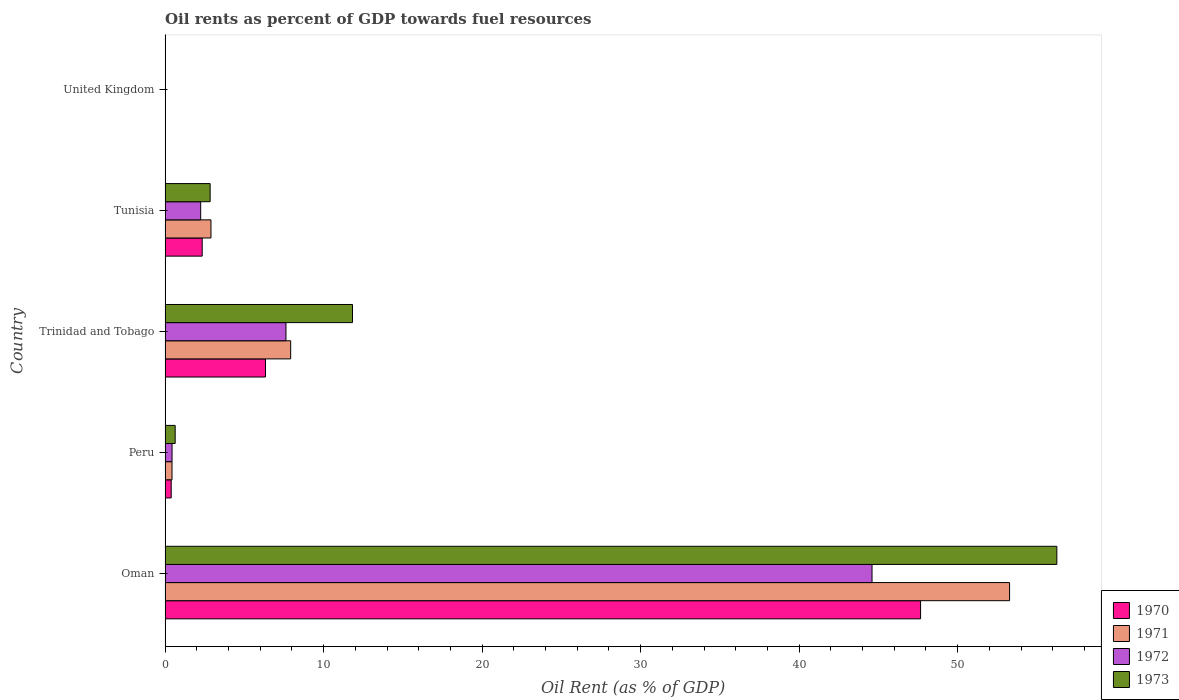Are the number of bars on each tick of the Y-axis equal?
Ensure brevity in your answer.  Yes. How many bars are there on the 2nd tick from the top?
Give a very brief answer. 4. What is the label of the 4th group of bars from the top?
Offer a terse response. Peru. In how many cases, is the number of bars for a given country not equal to the number of legend labels?
Your response must be concise. 0. What is the oil rent in 1970 in Trinidad and Tobago?
Provide a succinct answer. 6.33. Across all countries, what is the maximum oil rent in 1973?
Provide a succinct answer. 56.26. Across all countries, what is the minimum oil rent in 1970?
Provide a short and direct response. 0. In which country was the oil rent in 1973 maximum?
Your answer should be very brief. Oman. In which country was the oil rent in 1971 minimum?
Make the answer very short. United Kingdom. What is the total oil rent in 1973 in the graph?
Your answer should be compact. 71.56. What is the difference between the oil rent in 1970 in Peru and that in Tunisia?
Provide a short and direct response. -1.95. What is the difference between the oil rent in 1970 in United Kingdom and the oil rent in 1972 in Peru?
Your answer should be very brief. -0.44. What is the average oil rent in 1972 per country?
Provide a short and direct response. 10.98. What is the difference between the oil rent in 1971 and oil rent in 1972 in Tunisia?
Offer a terse response. 0.65. In how many countries, is the oil rent in 1972 greater than 12 %?
Ensure brevity in your answer.  1. What is the ratio of the oil rent in 1972 in Peru to that in Trinidad and Tobago?
Your response must be concise. 0.06. Is the oil rent in 1971 in Peru less than that in United Kingdom?
Provide a short and direct response. No. What is the difference between the highest and the second highest oil rent in 1970?
Your answer should be very brief. 41.33. What is the difference between the highest and the lowest oil rent in 1973?
Give a very brief answer. 56.26. Is the sum of the oil rent in 1971 in Oman and Trinidad and Tobago greater than the maximum oil rent in 1973 across all countries?
Keep it short and to the point. Yes. What does the 3rd bar from the bottom in Trinidad and Tobago represents?
Ensure brevity in your answer.  1972. Is it the case that in every country, the sum of the oil rent in 1970 and oil rent in 1971 is greater than the oil rent in 1973?
Provide a short and direct response. No. How many bars are there?
Offer a terse response. 20. Are all the bars in the graph horizontal?
Your answer should be compact. Yes. How many countries are there in the graph?
Provide a short and direct response. 5. Are the values on the major ticks of X-axis written in scientific E-notation?
Your answer should be very brief. No. Does the graph contain any zero values?
Provide a short and direct response. No. Where does the legend appear in the graph?
Keep it short and to the point. Bottom right. How many legend labels are there?
Your response must be concise. 4. What is the title of the graph?
Provide a succinct answer. Oil rents as percent of GDP towards fuel resources. Does "1974" appear as one of the legend labels in the graph?
Your answer should be compact. No. What is the label or title of the X-axis?
Your answer should be very brief. Oil Rent (as % of GDP). What is the Oil Rent (as % of GDP) in 1970 in Oman?
Provide a short and direct response. 47.66. What is the Oil Rent (as % of GDP) of 1971 in Oman?
Provide a short and direct response. 53.28. What is the Oil Rent (as % of GDP) of 1972 in Oman?
Your answer should be compact. 44.6. What is the Oil Rent (as % of GDP) in 1973 in Oman?
Offer a terse response. 56.26. What is the Oil Rent (as % of GDP) in 1970 in Peru?
Offer a terse response. 0.39. What is the Oil Rent (as % of GDP) of 1971 in Peru?
Provide a succinct answer. 0.44. What is the Oil Rent (as % of GDP) of 1972 in Peru?
Give a very brief answer. 0.44. What is the Oil Rent (as % of GDP) of 1973 in Peru?
Keep it short and to the point. 0.64. What is the Oil Rent (as % of GDP) of 1970 in Trinidad and Tobago?
Your answer should be very brief. 6.33. What is the Oil Rent (as % of GDP) in 1971 in Trinidad and Tobago?
Your answer should be compact. 7.92. What is the Oil Rent (as % of GDP) of 1972 in Trinidad and Tobago?
Keep it short and to the point. 7.63. What is the Oil Rent (as % of GDP) in 1973 in Trinidad and Tobago?
Provide a short and direct response. 11.82. What is the Oil Rent (as % of GDP) of 1970 in Tunisia?
Ensure brevity in your answer.  2.34. What is the Oil Rent (as % of GDP) in 1971 in Tunisia?
Keep it short and to the point. 2.89. What is the Oil Rent (as % of GDP) in 1972 in Tunisia?
Your answer should be very brief. 2.25. What is the Oil Rent (as % of GDP) in 1973 in Tunisia?
Your response must be concise. 2.84. What is the Oil Rent (as % of GDP) in 1970 in United Kingdom?
Your answer should be compact. 0. What is the Oil Rent (as % of GDP) of 1971 in United Kingdom?
Your answer should be very brief. 0. What is the Oil Rent (as % of GDP) of 1972 in United Kingdom?
Your answer should be compact. 0. What is the Oil Rent (as % of GDP) of 1973 in United Kingdom?
Offer a very short reply. 0. Across all countries, what is the maximum Oil Rent (as % of GDP) in 1970?
Your answer should be very brief. 47.66. Across all countries, what is the maximum Oil Rent (as % of GDP) of 1971?
Make the answer very short. 53.28. Across all countries, what is the maximum Oil Rent (as % of GDP) of 1972?
Your response must be concise. 44.6. Across all countries, what is the maximum Oil Rent (as % of GDP) in 1973?
Offer a very short reply. 56.26. Across all countries, what is the minimum Oil Rent (as % of GDP) of 1970?
Your response must be concise. 0. Across all countries, what is the minimum Oil Rent (as % of GDP) in 1971?
Your answer should be compact. 0. Across all countries, what is the minimum Oil Rent (as % of GDP) of 1972?
Your response must be concise. 0. Across all countries, what is the minimum Oil Rent (as % of GDP) of 1973?
Make the answer very short. 0. What is the total Oil Rent (as % of GDP) in 1970 in the graph?
Ensure brevity in your answer.  56.72. What is the total Oil Rent (as % of GDP) in 1971 in the graph?
Keep it short and to the point. 64.53. What is the total Oil Rent (as % of GDP) in 1972 in the graph?
Offer a very short reply. 54.91. What is the total Oil Rent (as % of GDP) of 1973 in the graph?
Offer a terse response. 71.56. What is the difference between the Oil Rent (as % of GDP) in 1970 in Oman and that in Peru?
Give a very brief answer. 47.28. What is the difference between the Oil Rent (as % of GDP) of 1971 in Oman and that in Peru?
Your answer should be very brief. 52.84. What is the difference between the Oil Rent (as % of GDP) in 1972 in Oman and that in Peru?
Offer a terse response. 44.16. What is the difference between the Oil Rent (as % of GDP) in 1973 in Oman and that in Peru?
Offer a terse response. 55.62. What is the difference between the Oil Rent (as % of GDP) in 1970 in Oman and that in Trinidad and Tobago?
Offer a very short reply. 41.33. What is the difference between the Oil Rent (as % of GDP) of 1971 in Oman and that in Trinidad and Tobago?
Provide a short and direct response. 45.35. What is the difference between the Oil Rent (as % of GDP) of 1972 in Oman and that in Trinidad and Tobago?
Give a very brief answer. 36.97. What is the difference between the Oil Rent (as % of GDP) in 1973 in Oman and that in Trinidad and Tobago?
Ensure brevity in your answer.  44.44. What is the difference between the Oil Rent (as % of GDP) of 1970 in Oman and that in Tunisia?
Offer a terse response. 45.32. What is the difference between the Oil Rent (as % of GDP) of 1971 in Oman and that in Tunisia?
Your response must be concise. 50.38. What is the difference between the Oil Rent (as % of GDP) in 1972 in Oman and that in Tunisia?
Offer a terse response. 42.36. What is the difference between the Oil Rent (as % of GDP) of 1973 in Oman and that in Tunisia?
Your response must be concise. 53.42. What is the difference between the Oil Rent (as % of GDP) in 1970 in Oman and that in United Kingdom?
Your answer should be compact. 47.66. What is the difference between the Oil Rent (as % of GDP) of 1971 in Oman and that in United Kingdom?
Give a very brief answer. 53.28. What is the difference between the Oil Rent (as % of GDP) in 1972 in Oman and that in United Kingdom?
Your response must be concise. 44.6. What is the difference between the Oil Rent (as % of GDP) of 1973 in Oman and that in United Kingdom?
Your answer should be compact. 56.26. What is the difference between the Oil Rent (as % of GDP) in 1970 in Peru and that in Trinidad and Tobago?
Make the answer very short. -5.95. What is the difference between the Oil Rent (as % of GDP) in 1971 in Peru and that in Trinidad and Tobago?
Keep it short and to the point. -7.49. What is the difference between the Oil Rent (as % of GDP) in 1972 in Peru and that in Trinidad and Tobago?
Your answer should be very brief. -7.19. What is the difference between the Oil Rent (as % of GDP) in 1973 in Peru and that in Trinidad and Tobago?
Your answer should be very brief. -11.19. What is the difference between the Oil Rent (as % of GDP) in 1970 in Peru and that in Tunisia?
Your answer should be compact. -1.95. What is the difference between the Oil Rent (as % of GDP) in 1971 in Peru and that in Tunisia?
Your answer should be compact. -2.46. What is the difference between the Oil Rent (as % of GDP) of 1972 in Peru and that in Tunisia?
Provide a short and direct response. -1.81. What is the difference between the Oil Rent (as % of GDP) in 1973 in Peru and that in Tunisia?
Keep it short and to the point. -2.21. What is the difference between the Oil Rent (as % of GDP) of 1970 in Peru and that in United Kingdom?
Your answer should be very brief. 0.38. What is the difference between the Oil Rent (as % of GDP) of 1971 in Peru and that in United Kingdom?
Keep it short and to the point. 0.44. What is the difference between the Oil Rent (as % of GDP) of 1972 in Peru and that in United Kingdom?
Provide a succinct answer. 0.44. What is the difference between the Oil Rent (as % of GDP) in 1973 in Peru and that in United Kingdom?
Your answer should be compact. 0.63. What is the difference between the Oil Rent (as % of GDP) of 1970 in Trinidad and Tobago and that in Tunisia?
Offer a very short reply. 3.99. What is the difference between the Oil Rent (as % of GDP) in 1971 in Trinidad and Tobago and that in Tunisia?
Offer a terse response. 5.03. What is the difference between the Oil Rent (as % of GDP) in 1972 in Trinidad and Tobago and that in Tunisia?
Your answer should be compact. 5.38. What is the difference between the Oil Rent (as % of GDP) of 1973 in Trinidad and Tobago and that in Tunisia?
Keep it short and to the point. 8.98. What is the difference between the Oil Rent (as % of GDP) of 1970 in Trinidad and Tobago and that in United Kingdom?
Offer a terse response. 6.33. What is the difference between the Oil Rent (as % of GDP) in 1971 in Trinidad and Tobago and that in United Kingdom?
Your answer should be compact. 7.92. What is the difference between the Oil Rent (as % of GDP) of 1972 in Trinidad and Tobago and that in United Kingdom?
Your answer should be very brief. 7.62. What is the difference between the Oil Rent (as % of GDP) of 1973 in Trinidad and Tobago and that in United Kingdom?
Offer a terse response. 11.82. What is the difference between the Oil Rent (as % of GDP) of 1970 in Tunisia and that in United Kingdom?
Keep it short and to the point. 2.34. What is the difference between the Oil Rent (as % of GDP) in 1971 in Tunisia and that in United Kingdom?
Give a very brief answer. 2.89. What is the difference between the Oil Rent (as % of GDP) in 1972 in Tunisia and that in United Kingdom?
Your response must be concise. 2.24. What is the difference between the Oil Rent (as % of GDP) in 1973 in Tunisia and that in United Kingdom?
Provide a short and direct response. 2.84. What is the difference between the Oil Rent (as % of GDP) of 1970 in Oman and the Oil Rent (as % of GDP) of 1971 in Peru?
Provide a succinct answer. 47.23. What is the difference between the Oil Rent (as % of GDP) of 1970 in Oman and the Oil Rent (as % of GDP) of 1972 in Peru?
Offer a very short reply. 47.22. What is the difference between the Oil Rent (as % of GDP) of 1970 in Oman and the Oil Rent (as % of GDP) of 1973 in Peru?
Offer a terse response. 47.03. What is the difference between the Oil Rent (as % of GDP) of 1971 in Oman and the Oil Rent (as % of GDP) of 1972 in Peru?
Your response must be concise. 52.84. What is the difference between the Oil Rent (as % of GDP) in 1971 in Oman and the Oil Rent (as % of GDP) in 1973 in Peru?
Give a very brief answer. 52.64. What is the difference between the Oil Rent (as % of GDP) in 1972 in Oman and the Oil Rent (as % of GDP) in 1973 in Peru?
Give a very brief answer. 43.96. What is the difference between the Oil Rent (as % of GDP) in 1970 in Oman and the Oil Rent (as % of GDP) in 1971 in Trinidad and Tobago?
Ensure brevity in your answer.  39.74. What is the difference between the Oil Rent (as % of GDP) in 1970 in Oman and the Oil Rent (as % of GDP) in 1972 in Trinidad and Tobago?
Offer a very short reply. 40.04. What is the difference between the Oil Rent (as % of GDP) in 1970 in Oman and the Oil Rent (as % of GDP) in 1973 in Trinidad and Tobago?
Offer a terse response. 35.84. What is the difference between the Oil Rent (as % of GDP) in 1971 in Oman and the Oil Rent (as % of GDP) in 1972 in Trinidad and Tobago?
Give a very brief answer. 45.65. What is the difference between the Oil Rent (as % of GDP) in 1971 in Oman and the Oil Rent (as % of GDP) in 1973 in Trinidad and Tobago?
Your answer should be very brief. 41.45. What is the difference between the Oil Rent (as % of GDP) in 1972 in Oman and the Oil Rent (as % of GDP) in 1973 in Trinidad and Tobago?
Your answer should be compact. 32.78. What is the difference between the Oil Rent (as % of GDP) of 1970 in Oman and the Oil Rent (as % of GDP) of 1971 in Tunisia?
Offer a terse response. 44.77. What is the difference between the Oil Rent (as % of GDP) in 1970 in Oman and the Oil Rent (as % of GDP) in 1972 in Tunisia?
Provide a succinct answer. 45.42. What is the difference between the Oil Rent (as % of GDP) in 1970 in Oman and the Oil Rent (as % of GDP) in 1973 in Tunisia?
Your answer should be very brief. 44.82. What is the difference between the Oil Rent (as % of GDP) in 1971 in Oman and the Oil Rent (as % of GDP) in 1972 in Tunisia?
Make the answer very short. 51.03. What is the difference between the Oil Rent (as % of GDP) of 1971 in Oman and the Oil Rent (as % of GDP) of 1973 in Tunisia?
Make the answer very short. 50.43. What is the difference between the Oil Rent (as % of GDP) of 1972 in Oman and the Oil Rent (as % of GDP) of 1973 in Tunisia?
Your answer should be very brief. 41.76. What is the difference between the Oil Rent (as % of GDP) in 1970 in Oman and the Oil Rent (as % of GDP) in 1971 in United Kingdom?
Provide a short and direct response. 47.66. What is the difference between the Oil Rent (as % of GDP) in 1970 in Oman and the Oil Rent (as % of GDP) in 1972 in United Kingdom?
Keep it short and to the point. 47.66. What is the difference between the Oil Rent (as % of GDP) in 1970 in Oman and the Oil Rent (as % of GDP) in 1973 in United Kingdom?
Offer a very short reply. 47.66. What is the difference between the Oil Rent (as % of GDP) in 1971 in Oman and the Oil Rent (as % of GDP) in 1972 in United Kingdom?
Your answer should be compact. 53.28. What is the difference between the Oil Rent (as % of GDP) in 1971 in Oman and the Oil Rent (as % of GDP) in 1973 in United Kingdom?
Offer a very short reply. 53.27. What is the difference between the Oil Rent (as % of GDP) of 1972 in Oman and the Oil Rent (as % of GDP) of 1973 in United Kingdom?
Offer a very short reply. 44.6. What is the difference between the Oil Rent (as % of GDP) in 1970 in Peru and the Oil Rent (as % of GDP) in 1971 in Trinidad and Tobago?
Keep it short and to the point. -7.54. What is the difference between the Oil Rent (as % of GDP) of 1970 in Peru and the Oil Rent (as % of GDP) of 1972 in Trinidad and Tobago?
Keep it short and to the point. -7.24. What is the difference between the Oil Rent (as % of GDP) in 1970 in Peru and the Oil Rent (as % of GDP) in 1973 in Trinidad and Tobago?
Offer a very short reply. -11.44. What is the difference between the Oil Rent (as % of GDP) in 1971 in Peru and the Oil Rent (as % of GDP) in 1972 in Trinidad and Tobago?
Keep it short and to the point. -7.19. What is the difference between the Oil Rent (as % of GDP) of 1971 in Peru and the Oil Rent (as % of GDP) of 1973 in Trinidad and Tobago?
Make the answer very short. -11.39. What is the difference between the Oil Rent (as % of GDP) of 1972 in Peru and the Oil Rent (as % of GDP) of 1973 in Trinidad and Tobago?
Your answer should be very brief. -11.38. What is the difference between the Oil Rent (as % of GDP) of 1970 in Peru and the Oil Rent (as % of GDP) of 1971 in Tunisia?
Give a very brief answer. -2.51. What is the difference between the Oil Rent (as % of GDP) in 1970 in Peru and the Oil Rent (as % of GDP) in 1972 in Tunisia?
Keep it short and to the point. -1.86. What is the difference between the Oil Rent (as % of GDP) in 1970 in Peru and the Oil Rent (as % of GDP) in 1973 in Tunisia?
Offer a terse response. -2.46. What is the difference between the Oil Rent (as % of GDP) of 1971 in Peru and the Oil Rent (as % of GDP) of 1972 in Tunisia?
Provide a short and direct response. -1.81. What is the difference between the Oil Rent (as % of GDP) of 1971 in Peru and the Oil Rent (as % of GDP) of 1973 in Tunisia?
Your response must be concise. -2.4. What is the difference between the Oil Rent (as % of GDP) in 1972 in Peru and the Oil Rent (as % of GDP) in 1973 in Tunisia?
Ensure brevity in your answer.  -2.4. What is the difference between the Oil Rent (as % of GDP) of 1970 in Peru and the Oil Rent (as % of GDP) of 1971 in United Kingdom?
Ensure brevity in your answer.  0.38. What is the difference between the Oil Rent (as % of GDP) in 1970 in Peru and the Oil Rent (as % of GDP) in 1972 in United Kingdom?
Provide a short and direct response. 0.38. What is the difference between the Oil Rent (as % of GDP) in 1970 in Peru and the Oil Rent (as % of GDP) in 1973 in United Kingdom?
Make the answer very short. 0.38. What is the difference between the Oil Rent (as % of GDP) of 1971 in Peru and the Oil Rent (as % of GDP) of 1972 in United Kingdom?
Ensure brevity in your answer.  0.44. What is the difference between the Oil Rent (as % of GDP) in 1971 in Peru and the Oil Rent (as % of GDP) in 1973 in United Kingdom?
Provide a succinct answer. 0.43. What is the difference between the Oil Rent (as % of GDP) in 1972 in Peru and the Oil Rent (as % of GDP) in 1973 in United Kingdom?
Your answer should be compact. 0.44. What is the difference between the Oil Rent (as % of GDP) of 1970 in Trinidad and Tobago and the Oil Rent (as % of GDP) of 1971 in Tunisia?
Give a very brief answer. 3.44. What is the difference between the Oil Rent (as % of GDP) in 1970 in Trinidad and Tobago and the Oil Rent (as % of GDP) in 1972 in Tunisia?
Provide a short and direct response. 4.09. What is the difference between the Oil Rent (as % of GDP) in 1970 in Trinidad and Tobago and the Oil Rent (as % of GDP) in 1973 in Tunisia?
Offer a terse response. 3.49. What is the difference between the Oil Rent (as % of GDP) of 1971 in Trinidad and Tobago and the Oil Rent (as % of GDP) of 1972 in Tunisia?
Keep it short and to the point. 5.68. What is the difference between the Oil Rent (as % of GDP) in 1971 in Trinidad and Tobago and the Oil Rent (as % of GDP) in 1973 in Tunisia?
Provide a short and direct response. 5.08. What is the difference between the Oil Rent (as % of GDP) in 1972 in Trinidad and Tobago and the Oil Rent (as % of GDP) in 1973 in Tunisia?
Provide a short and direct response. 4.78. What is the difference between the Oil Rent (as % of GDP) in 1970 in Trinidad and Tobago and the Oil Rent (as % of GDP) in 1971 in United Kingdom?
Offer a very short reply. 6.33. What is the difference between the Oil Rent (as % of GDP) of 1970 in Trinidad and Tobago and the Oil Rent (as % of GDP) of 1972 in United Kingdom?
Provide a short and direct response. 6.33. What is the difference between the Oil Rent (as % of GDP) in 1970 in Trinidad and Tobago and the Oil Rent (as % of GDP) in 1973 in United Kingdom?
Provide a short and direct response. 6.33. What is the difference between the Oil Rent (as % of GDP) of 1971 in Trinidad and Tobago and the Oil Rent (as % of GDP) of 1972 in United Kingdom?
Keep it short and to the point. 7.92. What is the difference between the Oil Rent (as % of GDP) in 1971 in Trinidad and Tobago and the Oil Rent (as % of GDP) in 1973 in United Kingdom?
Your response must be concise. 7.92. What is the difference between the Oil Rent (as % of GDP) in 1972 in Trinidad and Tobago and the Oil Rent (as % of GDP) in 1973 in United Kingdom?
Make the answer very short. 7.62. What is the difference between the Oil Rent (as % of GDP) of 1970 in Tunisia and the Oil Rent (as % of GDP) of 1971 in United Kingdom?
Offer a very short reply. 2.34. What is the difference between the Oil Rent (as % of GDP) of 1970 in Tunisia and the Oil Rent (as % of GDP) of 1972 in United Kingdom?
Your response must be concise. 2.34. What is the difference between the Oil Rent (as % of GDP) in 1970 in Tunisia and the Oil Rent (as % of GDP) in 1973 in United Kingdom?
Your response must be concise. 2.34. What is the difference between the Oil Rent (as % of GDP) in 1971 in Tunisia and the Oil Rent (as % of GDP) in 1972 in United Kingdom?
Offer a terse response. 2.89. What is the difference between the Oil Rent (as % of GDP) of 1971 in Tunisia and the Oil Rent (as % of GDP) of 1973 in United Kingdom?
Provide a succinct answer. 2.89. What is the difference between the Oil Rent (as % of GDP) of 1972 in Tunisia and the Oil Rent (as % of GDP) of 1973 in United Kingdom?
Your response must be concise. 2.24. What is the average Oil Rent (as % of GDP) in 1970 per country?
Your answer should be very brief. 11.34. What is the average Oil Rent (as % of GDP) of 1971 per country?
Provide a short and direct response. 12.91. What is the average Oil Rent (as % of GDP) of 1972 per country?
Your response must be concise. 10.98. What is the average Oil Rent (as % of GDP) in 1973 per country?
Your answer should be compact. 14.31. What is the difference between the Oil Rent (as % of GDP) in 1970 and Oil Rent (as % of GDP) in 1971 in Oman?
Your answer should be compact. -5.61. What is the difference between the Oil Rent (as % of GDP) of 1970 and Oil Rent (as % of GDP) of 1972 in Oman?
Your response must be concise. 3.06. What is the difference between the Oil Rent (as % of GDP) of 1970 and Oil Rent (as % of GDP) of 1973 in Oman?
Your response must be concise. -8.6. What is the difference between the Oil Rent (as % of GDP) of 1971 and Oil Rent (as % of GDP) of 1972 in Oman?
Ensure brevity in your answer.  8.68. What is the difference between the Oil Rent (as % of GDP) in 1971 and Oil Rent (as % of GDP) in 1973 in Oman?
Make the answer very short. -2.98. What is the difference between the Oil Rent (as % of GDP) of 1972 and Oil Rent (as % of GDP) of 1973 in Oman?
Ensure brevity in your answer.  -11.66. What is the difference between the Oil Rent (as % of GDP) in 1970 and Oil Rent (as % of GDP) in 1971 in Peru?
Keep it short and to the point. -0.05. What is the difference between the Oil Rent (as % of GDP) of 1970 and Oil Rent (as % of GDP) of 1972 in Peru?
Give a very brief answer. -0.05. What is the difference between the Oil Rent (as % of GDP) of 1970 and Oil Rent (as % of GDP) of 1973 in Peru?
Make the answer very short. -0.25. What is the difference between the Oil Rent (as % of GDP) in 1971 and Oil Rent (as % of GDP) in 1972 in Peru?
Your answer should be very brief. -0. What is the difference between the Oil Rent (as % of GDP) in 1971 and Oil Rent (as % of GDP) in 1973 in Peru?
Your answer should be very brief. -0.2. What is the difference between the Oil Rent (as % of GDP) in 1972 and Oil Rent (as % of GDP) in 1973 in Peru?
Your response must be concise. -0.2. What is the difference between the Oil Rent (as % of GDP) of 1970 and Oil Rent (as % of GDP) of 1971 in Trinidad and Tobago?
Your answer should be very brief. -1.59. What is the difference between the Oil Rent (as % of GDP) in 1970 and Oil Rent (as % of GDP) in 1972 in Trinidad and Tobago?
Your response must be concise. -1.29. What is the difference between the Oil Rent (as % of GDP) of 1970 and Oil Rent (as % of GDP) of 1973 in Trinidad and Tobago?
Offer a terse response. -5.49. What is the difference between the Oil Rent (as % of GDP) in 1971 and Oil Rent (as % of GDP) in 1972 in Trinidad and Tobago?
Give a very brief answer. 0.3. What is the difference between the Oil Rent (as % of GDP) in 1971 and Oil Rent (as % of GDP) in 1973 in Trinidad and Tobago?
Provide a short and direct response. -3.9. What is the difference between the Oil Rent (as % of GDP) of 1972 and Oil Rent (as % of GDP) of 1973 in Trinidad and Tobago?
Your response must be concise. -4.2. What is the difference between the Oil Rent (as % of GDP) in 1970 and Oil Rent (as % of GDP) in 1971 in Tunisia?
Your answer should be very brief. -0.55. What is the difference between the Oil Rent (as % of GDP) in 1970 and Oil Rent (as % of GDP) in 1972 in Tunisia?
Make the answer very short. 0.1. What is the difference between the Oil Rent (as % of GDP) of 1970 and Oil Rent (as % of GDP) of 1973 in Tunisia?
Your answer should be very brief. -0.5. What is the difference between the Oil Rent (as % of GDP) of 1971 and Oil Rent (as % of GDP) of 1972 in Tunisia?
Ensure brevity in your answer.  0.65. What is the difference between the Oil Rent (as % of GDP) in 1971 and Oil Rent (as % of GDP) in 1973 in Tunisia?
Make the answer very short. 0.05. What is the difference between the Oil Rent (as % of GDP) in 1972 and Oil Rent (as % of GDP) in 1973 in Tunisia?
Give a very brief answer. -0.6. What is the difference between the Oil Rent (as % of GDP) in 1970 and Oil Rent (as % of GDP) in 1971 in United Kingdom?
Offer a terse response. 0. What is the difference between the Oil Rent (as % of GDP) in 1970 and Oil Rent (as % of GDP) in 1972 in United Kingdom?
Give a very brief answer. -0. What is the difference between the Oil Rent (as % of GDP) of 1970 and Oil Rent (as % of GDP) of 1973 in United Kingdom?
Give a very brief answer. -0. What is the difference between the Oil Rent (as % of GDP) in 1971 and Oil Rent (as % of GDP) in 1972 in United Kingdom?
Offer a terse response. -0. What is the difference between the Oil Rent (as % of GDP) in 1971 and Oil Rent (as % of GDP) in 1973 in United Kingdom?
Offer a very short reply. -0. What is the difference between the Oil Rent (as % of GDP) of 1972 and Oil Rent (as % of GDP) of 1973 in United Kingdom?
Offer a terse response. -0. What is the ratio of the Oil Rent (as % of GDP) in 1970 in Oman to that in Peru?
Your answer should be compact. 123.65. What is the ratio of the Oil Rent (as % of GDP) of 1971 in Oman to that in Peru?
Your answer should be compact. 121.98. What is the ratio of the Oil Rent (as % of GDP) in 1972 in Oman to that in Peru?
Make the answer very short. 101.64. What is the ratio of the Oil Rent (as % of GDP) in 1973 in Oman to that in Peru?
Provide a succinct answer. 88.49. What is the ratio of the Oil Rent (as % of GDP) in 1970 in Oman to that in Trinidad and Tobago?
Offer a very short reply. 7.52. What is the ratio of the Oil Rent (as % of GDP) in 1971 in Oman to that in Trinidad and Tobago?
Make the answer very short. 6.73. What is the ratio of the Oil Rent (as % of GDP) of 1972 in Oman to that in Trinidad and Tobago?
Your answer should be very brief. 5.85. What is the ratio of the Oil Rent (as % of GDP) of 1973 in Oman to that in Trinidad and Tobago?
Keep it short and to the point. 4.76. What is the ratio of the Oil Rent (as % of GDP) in 1970 in Oman to that in Tunisia?
Give a very brief answer. 20.37. What is the ratio of the Oil Rent (as % of GDP) in 1971 in Oman to that in Tunisia?
Your response must be concise. 18.41. What is the ratio of the Oil Rent (as % of GDP) of 1972 in Oman to that in Tunisia?
Offer a terse response. 19.87. What is the ratio of the Oil Rent (as % of GDP) of 1973 in Oman to that in Tunisia?
Provide a succinct answer. 19.8. What is the ratio of the Oil Rent (as % of GDP) in 1970 in Oman to that in United Kingdom?
Your answer should be very brief. 5.38e+04. What is the ratio of the Oil Rent (as % of GDP) in 1971 in Oman to that in United Kingdom?
Provide a short and direct response. 7.53e+04. What is the ratio of the Oil Rent (as % of GDP) of 1972 in Oman to that in United Kingdom?
Provide a succinct answer. 3.45e+04. What is the ratio of the Oil Rent (as % of GDP) of 1973 in Oman to that in United Kingdom?
Make the answer very short. 2.51e+04. What is the ratio of the Oil Rent (as % of GDP) in 1970 in Peru to that in Trinidad and Tobago?
Ensure brevity in your answer.  0.06. What is the ratio of the Oil Rent (as % of GDP) in 1971 in Peru to that in Trinidad and Tobago?
Your answer should be very brief. 0.06. What is the ratio of the Oil Rent (as % of GDP) of 1972 in Peru to that in Trinidad and Tobago?
Your answer should be compact. 0.06. What is the ratio of the Oil Rent (as % of GDP) in 1973 in Peru to that in Trinidad and Tobago?
Keep it short and to the point. 0.05. What is the ratio of the Oil Rent (as % of GDP) in 1970 in Peru to that in Tunisia?
Provide a succinct answer. 0.16. What is the ratio of the Oil Rent (as % of GDP) in 1971 in Peru to that in Tunisia?
Offer a very short reply. 0.15. What is the ratio of the Oil Rent (as % of GDP) in 1972 in Peru to that in Tunisia?
Your response must be concise. 0.2. What is the ratio of the Oil Rent (as % of GDP) of 1973 in Peru to that in Tunisia?
Make the answer very short. 0.22. What is the ratio of the Oil Rent (as % of GDP) in 1970 in Peru to that in United Kingdom?
Offer a terse response. 435.22. What is the ratio of the Oil Rent (as % of GDP) of 1971 in Peru to that in United Kingdom?
Keep it short and to the point. 617.08. What is the ratio of the Oil Rent (as % of GDP) of 1972 in Peru to that in United Kingdom?
Offer a terse response. 339.21. What is the ratio of the Oil Rent (as % of GDP) of 1973 in Peru to that in United Kingdom?
Offer a terse response. 283.34. What is the ratio of the Oil Rent (as % of GDP) of 1970 in Trinidad and Tobago to that in Tunisia?
Offer a terse response. 2.71. What is the ratio of the Oil Rent (as % of GDP) in 1971 in Trinidad and Tobago to that in Tunisia?
Ensure brevity in your answer.  2.74. What is the ratio of the Oil Rent (as % of GDP) in 1972 in Trinidad and Tobago to that in Tunisia?
Your response must be concise. 3.4. What is the ratio of the Oil Rent (as % of GDP) of 1973 in Trinidad and Tobago to that in Tunisia?
Provide a short and direct response. 4.16. What is the ratio of the Oil Rent (as % of GDP) in 1970 in Trinidad and Tobago to that in United Kingdom?
Your answer should be very brief. 7151.98. What is the ratio of the Oil Rent (as % of GDP) of 1971 in Trinidad and Tobago to that in United Kingdom?
Your response must be concise. 1.12e+04. What is the ratio of the Oil Rent (as % of GDP) in 1972 in Trinidad and Tobago to that in United Kingdom?
Provide a short and direct response. 5894.4. What is the ratio of the Oil Rent (as % of GDP) of 1973 in Trinidad and Tobago to that in United Kingdom?
Provide a short and direct response. 5268.85. What is the ratio of the Oil Rent (as % of GDP) in 1970 in Tunisia to that in United Kingdom?
Offer a very short reply. 2642.42. What is the ratio of the Oil Rent (as % of GDP) in 1971 in Tunisia to that in United Kingdom?
Offer a very short reply. 4088.61. What is the ratio of the Oil Rent (as % of GDP) of 1972 in Tunisia to that in United Kingdom?
Your answer should be very brief. 1735.44. What is the ratio of the Oil Rent (as % of GDP) in 1973 in Tunisia to that in United Kingdom?
Your answer should be very brief. 1266.39. What is the difference between the highest and the second highest Oil Rent (as % of GDP) of 1970?
Provide a short and direct response. 41.33. What is the difference between the highest and the second highest Oil Rent (as % of GDP) of 1971?
Provide a short and direct response. 45.35. What is the difference between the highest and the second highest Oil Rent (as % of GDP) of 1972?
Offer a terse response. 36.97. What is the difference between the highest and the second highest Oil Rent (as % of GDP) of 1973?
Offer a very short reply. 44.44. What is the difference between the highest and the lowest Oil Rent (as % of GDP) of 1970?
Offer a terse response. 47.66. What is the difference between the highest and the lowest Oil Rent (as % of GDP) of 1971?
Give a very brief answer. 53.28. What is the difference between the highest and the lowest Oil Rent (as % of GDP) of 1972?
Offer a terse response. 44.6. What is the difference between the highest and the lowest Oil Rent (as % of GDP) of 1973?
Make the answer very short. 56.26. 